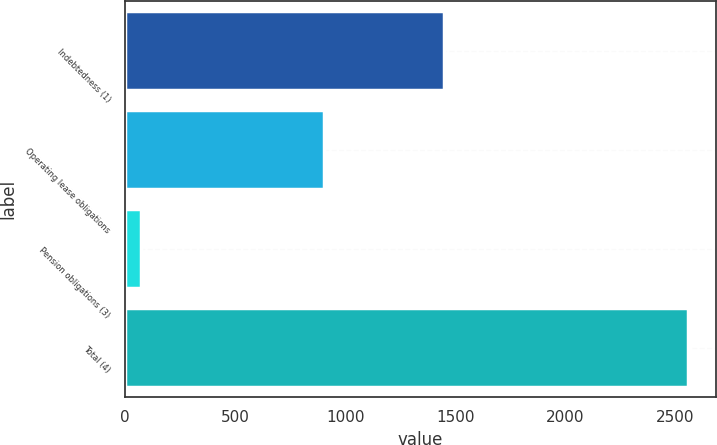<chart> <loc_0><loc_0><loc_500><loc_500><bar_chart><fcel>Indebtedness (1)<fcel>Operating lease obligations<fcel>Pension obligations (3)<fcel>Total (4)<nl><fcel>1447.1<fcel>905.2<fcel>74.2<fcel>2556.8<nl></chart> 